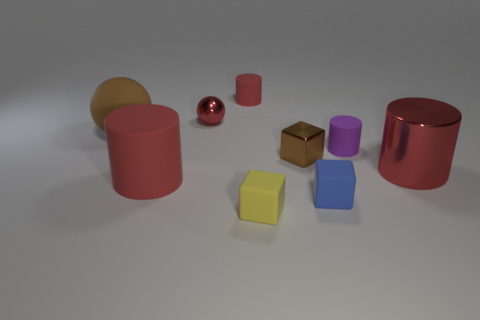Subtract all brown blocks. How many red cylinders are left? 3 Subtract 1 cylinders. How many cylinders are left? 3 Add 1 purple metallic cubes. How many objects exist? 10 Subtract all balls. How many objects are left? 7 Add 4 small brown metallic blocks. How many small brown metallic blocks exist? 5 Subtract 0 cyan spheres. How many objects are left? 9 Subtract all red metallic cylinders. Subtract all big yellow objects. How many objects are left? 8 Add 2 cylinders. How many cylinders are left? 6 